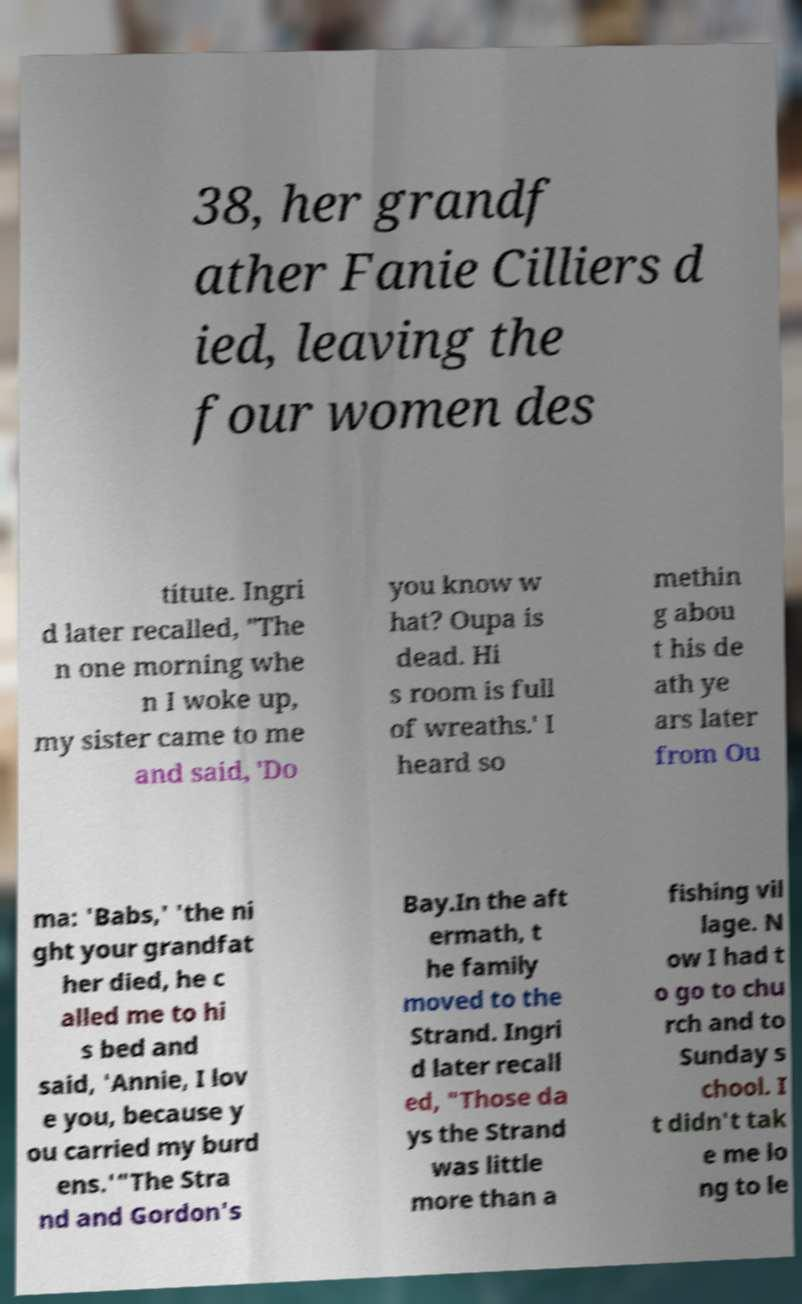Please identify and transcribe the text found in this image. 38, her grandf ather Fanie Cilliers d ied, leaving the four women des titute. Ingri d later recalled, "The n one morning whe n I woke up, my sister came to me and said, 'Do you know w hat? Oupa is dead. Hi s room is full of wreaths.' I heard so methin g abou t his de ath ye ars later from Ou ma: 'Babs,' 'the ni ght your grandfat her died, he c alled me to hi s bed and said, 'Annie, I lov e you, because y ou carried my burd ens.'"The Stra nd and Gordon's Bay.In the aft ermath, t he family moved to the Strand. Ingri d later recall ed, "Those da ys the Strand was little more than a fishing vil lage. N ow I had t o go to chu rch and to Sunday s chool. I t didn't tak e me lo ng to le 